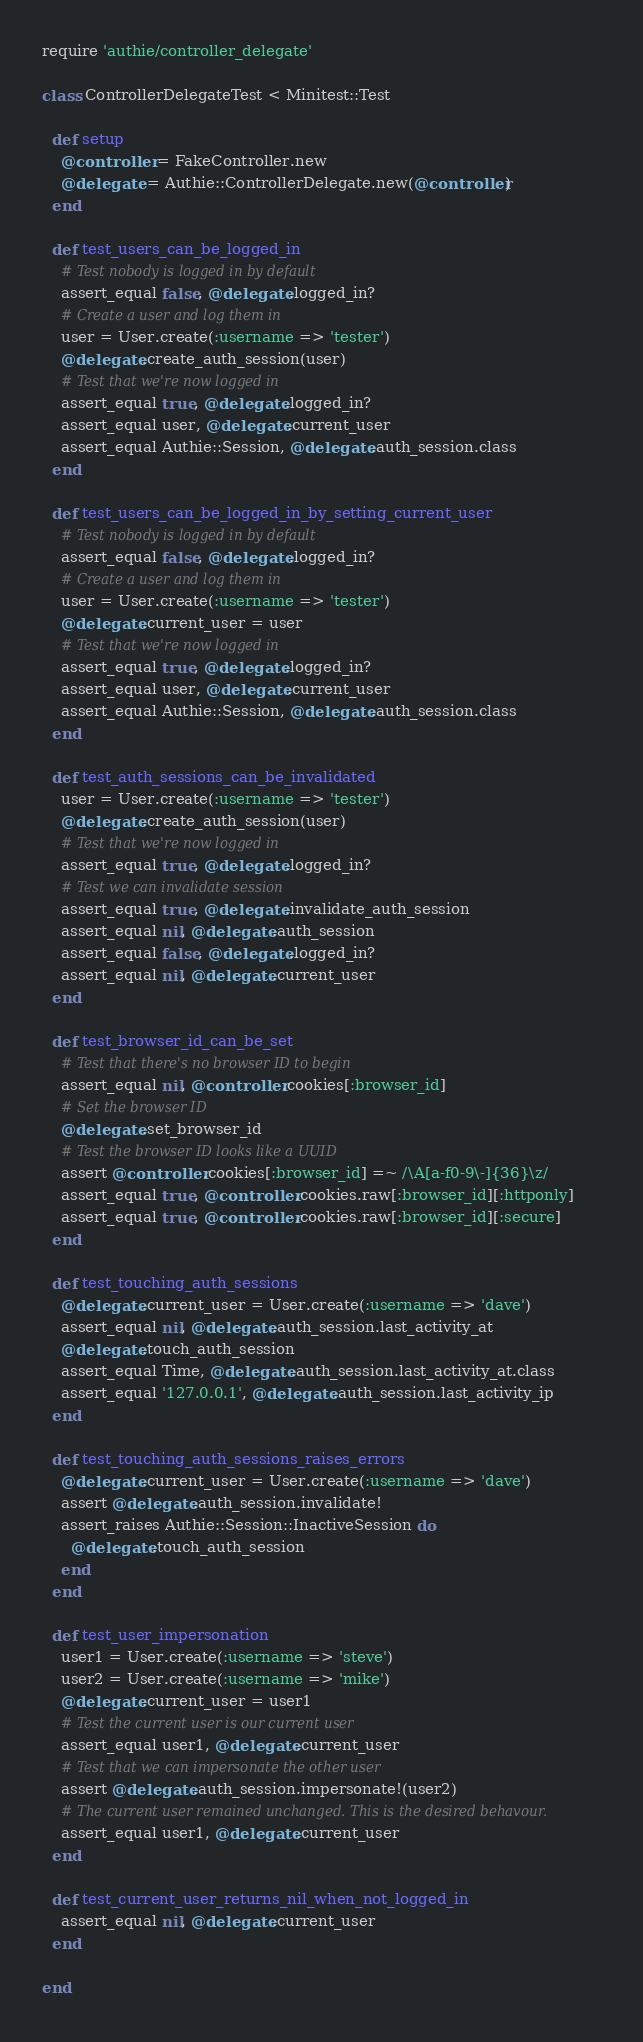<code> <loc_0><loc_0><loc_500><loc_500><_Ruby_>require 'authie/controller_delegate'

class ControllerDelegateTest < Minitest::Test

  def setup
    @controller = FakeController.new
    @delegate = Authie::ControllerDelegate.new(@controller)
  end

  def test_users_can_be_logged_in
    # Test nobody is logged in by default
    assert_equal false, @delegate.logged_in?
    # Create a user and log them in
    user = User.create(:username => 'tester')
    @delegate.create_auth_session(user)
    # Test that we're now logged in
    assert_equal true, @delegate.logged_in?
    assert_equal user, @delegate.current_user
    assert_equal Authie::Session, @delegate.auth_session.class
  end

  def test_users_can_be_logged_in_by_setting_current_user
    # Test nobody is logged in by default
    assert_equal false, @delegate.logged_in?
    # Create a user and log them in
    user = User.create(:username => 'tester')
    @delegate.current_user = user
    # Test that we're now logged in
    assert_equal true, @delegate.logged_in?
    assert_equal user, @delegate.current_user
    assert_equal Authie::Session, @delegate.auth_session.class
  end

  def test_auth_sessions_can_be_invalidated
    user = User.create(:username => 'tester')
    @delegate.create_auth_session(user)
    # Test that we're now logged in
    assert_equal true, @delegate.logged_in?
    # Test we can invalidate session
    assert_equal true, @delegate.invalidate_auth_session
    assert_equal nil, @delegate.auth_session
    assert_equal false, @delegate.logged_in?
    assert_equal nil, @delegate.current_user
  end

  def test_browser_id_can_be_set
    # Test that there's no browser ID to begin
    assert_equal nil, @controller.cookies[:browser_id]
    # Set the browser ID
    @delegate.set_browser_id
    # Test the browser ID looks like a UUID
    assert @controller.cookies[:browser_id] =~ /\A[a-f0-9\-]{36}\z/
    assert_equal true, @controller.cookies.raw[:browser_id][:httponly]
    assert_equal true, @controller.cookies.raw[:browser_id][:secure]
  end

  def test_touching_auth_sessions
    @delegate.current_user = User.create(:username => 'dave')
    assert_equal nil, @delegate.auth_session.last_activity_at
    @delegate.touch_auth_session
    assert_equal Time, @delegate.auth_session.last_activity_at.class
    assert_equal '127.0.0.1', @delegate.auth_session.last_activity_ip
  end

  def test_touching_auth_sessions_raises_errors
    @delegate.current_user = User.create(:username => 'dave')
    assert @delegate.auth_session.invalidate!
    assert_raises Authie::Session::InactiveSession do
      @delegate.touch_auth_session
    end
  end

  def test_user_impersonation
    user1 = User.create(:username => 'steve')
    user2 = User.create(:username => 'mike')
    @delegate.current_user = user1
    # Test the current user is our current user
    assert_equal user1, @delegate.current_user
    # Test that we can impersonate the other user
    assert @delegate.auth_session.impersonate!(user2)
    # The current user remained unchanged. This is the desired behavour.
    assert_equal user1, @delegate.current_user
  end

  def test_current_user_returns_nil_when_not_logged_in
    assert_equal nil, @delegate.current_user
  end

end
</code> 